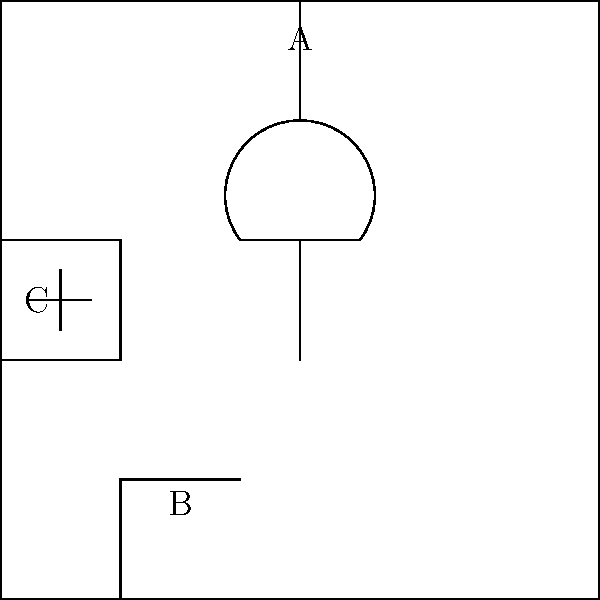Caro nonno, guardando questo schema elettrico di un semplice sistema domestico, puoi identificare quale componente è rappresentato dalla lettera "B"? È qualcosa che usiamo spesso per accendere e spegnere le luci in casa. Per rispondere a questa domanda, dobbiamo analizzare lo schema elettrico passo dopo passo:

1. Osserviamo che ci sono tre componenti principali etichettati A, B e C.

2. Il componente A è rappresentato da un simbolo che assomiglia a un cerchio con una croce all'interno. Questo è il simbolo standard per una lampadina o una luce.

3. Il componente C è rappresentato da due linee parallele di lunghezza diversa, con un simbolo "+" vicino alla linea più lunga. Questo è il simbolo standard per una batteria o una fonte di alimentazione.

4. Il componente B è rappresentato da un simbolo che mostra una linea interrotta con un piccolo arco. Questo simbolo rappresenta un interruttore.

5. L'interruttore è un dispositivo che usiamo comunemente nelle case per accendere e spegnere le luci. È posizionato tra la fonte di alimentazione e la lampadina per controllare il flusso di corrente.

Quindi, il componente B rappresenta un interruttore, che è esattamente ciò che usiamo per accendere e spegnere le luci in casa.
Answer: Interruttore 